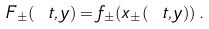Convert formula to latex. <formula><loc_0><loc_0><loc_500><loc_500>F _ { \pm } ( \ t , y ) = f _ { \pm } ( x _ { \pm } ( \ t , y ) ) \, .</formula> 